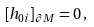<formula> <loc_0><loc_0><loc_500><loc_500>\left [ h _ { 0 i } \right ] _ { \partial M } = 0 \, ,</formula> 